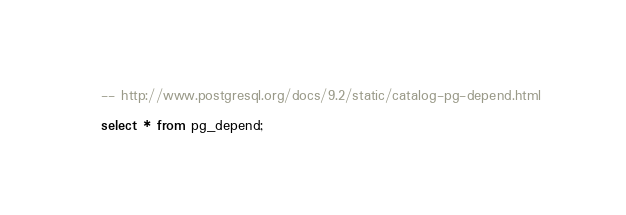<code> <loc_0><loc_0><loc_500><loc_500><_SQL_>-- http://www.postgresql.org/docs/9.2/static/catalog-pg-depend.html

select * from pg_depend;</code> 